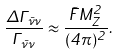Convert formula to latex. <formula><loc_0><loc_0><loc_500><loc_500>\frac { \Delta \Gamma _ { \bar { \nu } \nu } } { \Gamma _ { \bar { \nu } \nu } } \approx \frac { \tilde { F } M _ { Z } ^ { 2 } } { ( 4 \pi ) ^ { 2 } } .</formula> 